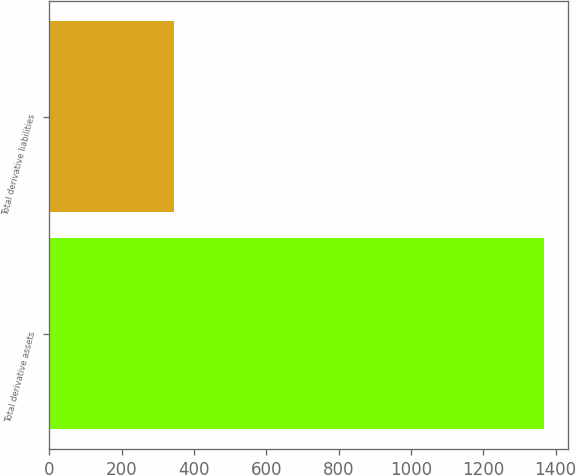Convert chart to OTSL. <chart><loc_0><loc_0><loc_500><loc_500><bar_chart><fcel>Total derivative assets<fcel>Total derivative liabilities<nl><fcel>1367<fcel>345<nl></chart> 